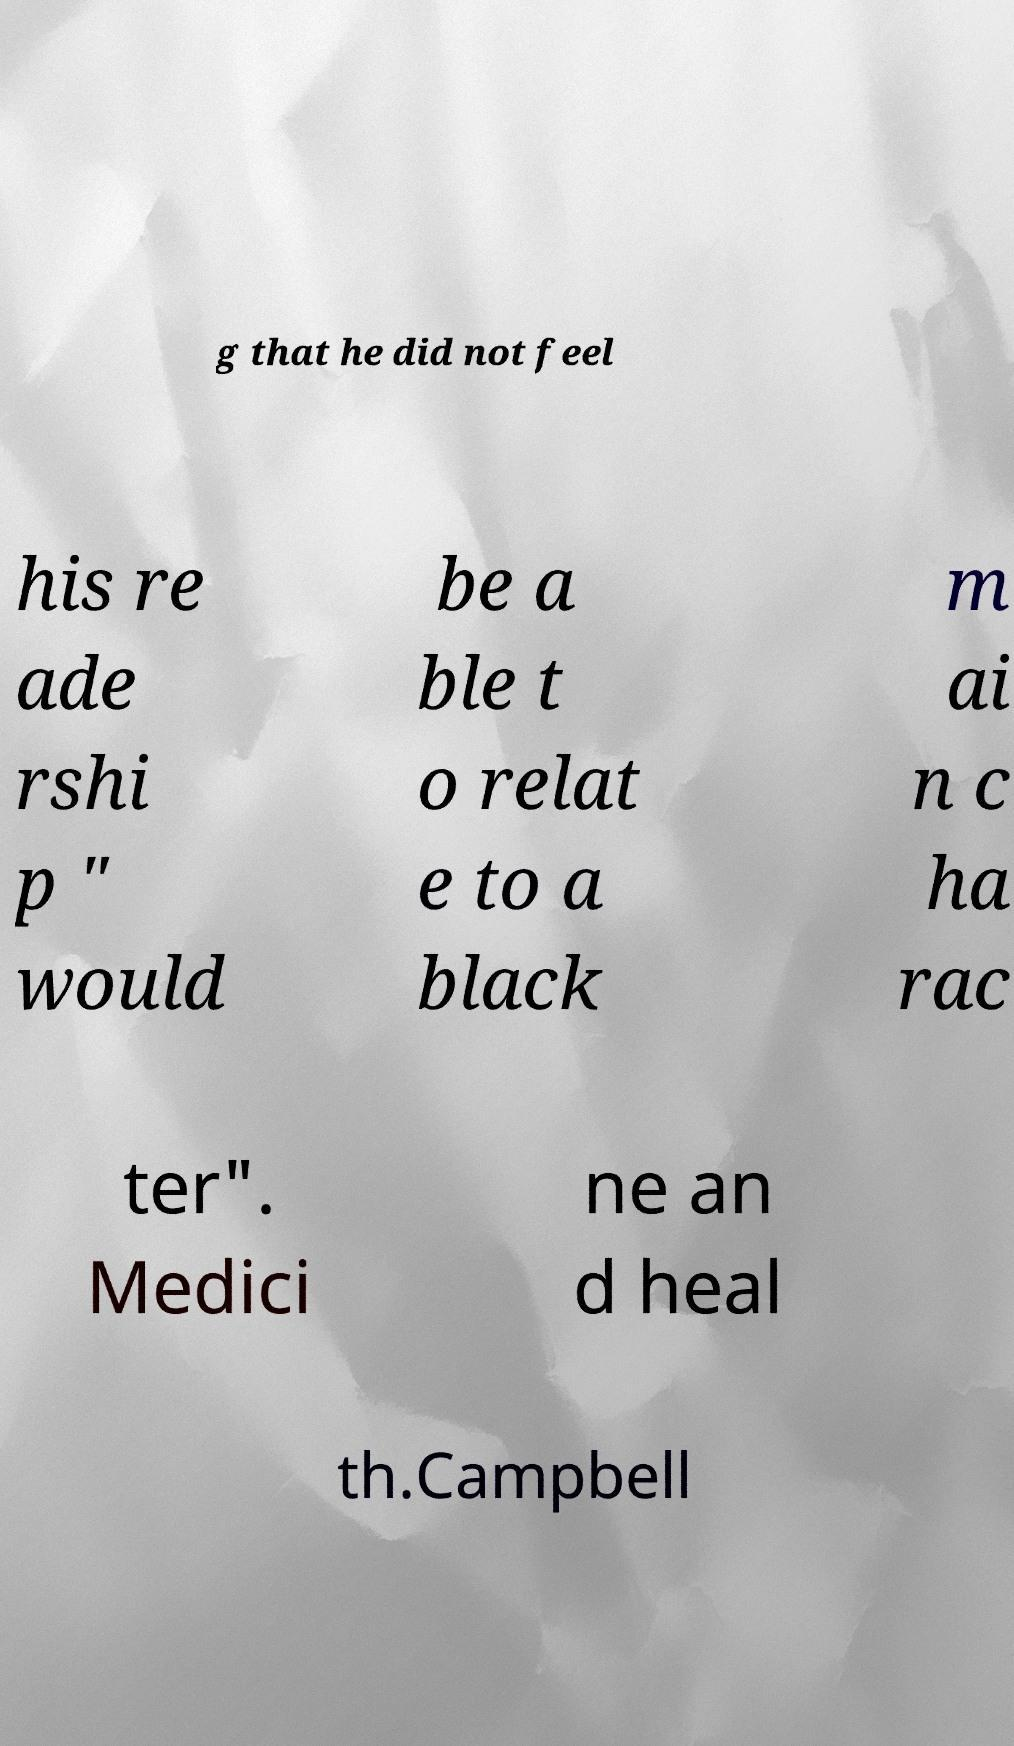Could you assist in decoding the text presented in this image and type it out clearly? g that he did not feel his re ade rshi p " would be a ble t o relat e to a black m ai n c ha rac ter". Medici ne an d heal th.Campbell 